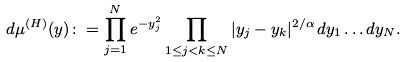<formula> <loc_0><loc_0><loc_500><loc_500>d \mu ^ { ( H ) } ( y ) \colon = \prod _ { j = 1 } ^ { N } e ^ { - y _ { j } ^ { 2 } } \prod _ { 1 \leq j < k \leq N } | y _ { j } - y _ { k } | ^ { 2 / \alpha } \, d y _ { 1 } \dots d y _ { N } .</formula> 